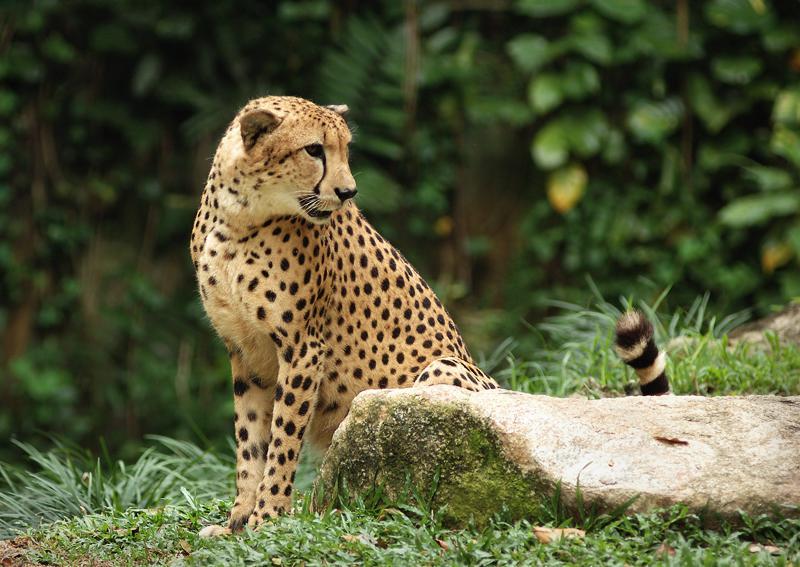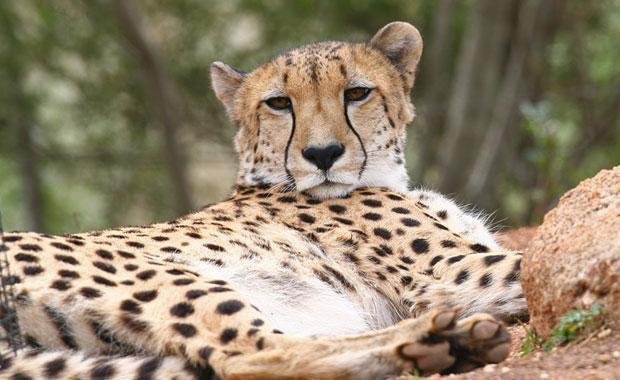The first image is the image on the left, the second image is the image on the right. Analyze the images presented: Is the assertion "At least one of the animals is in mid-leap." valid? Answer yes or no. No. 